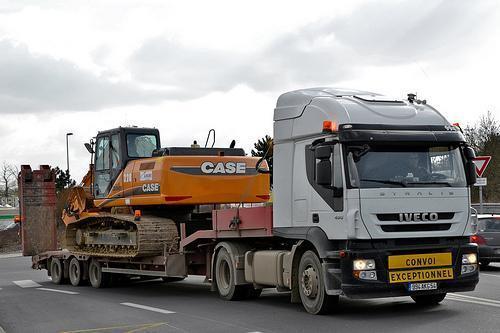How many tractors are on the truck?
Give a very brief answer. 1. 